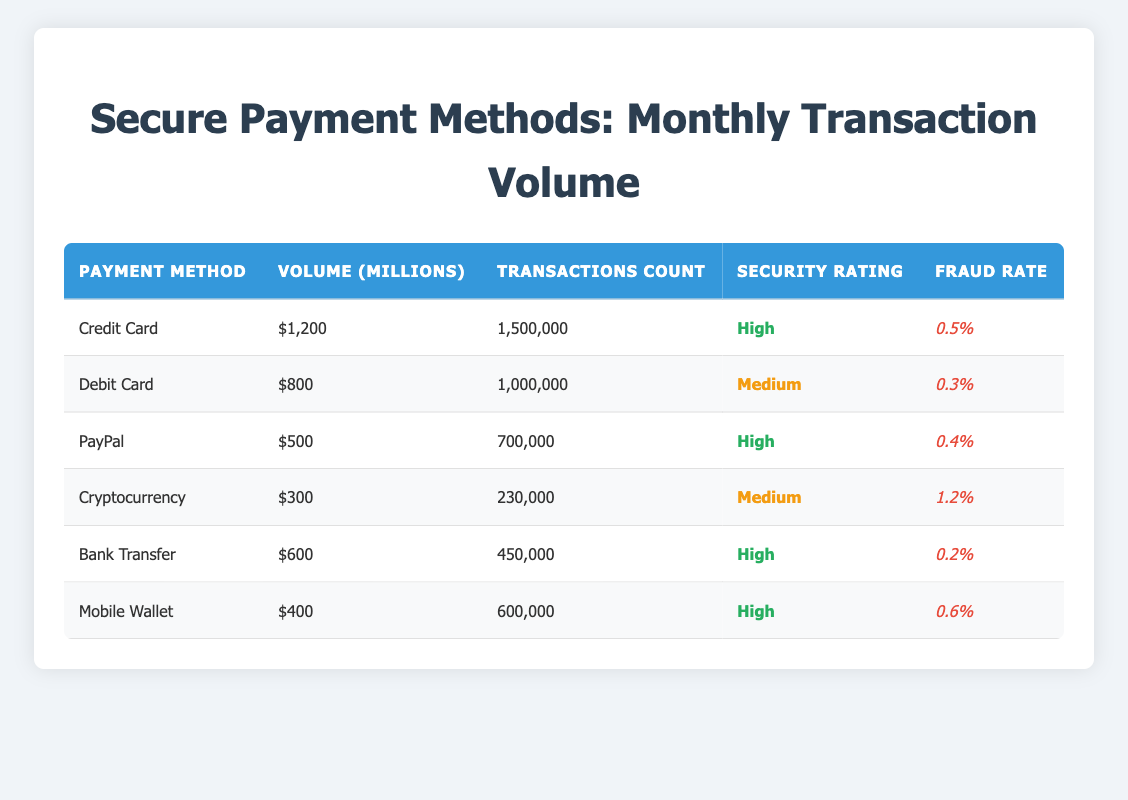What is the payment method with the highest transaction volume? The transaction volumes are as follows: Credit Card - 1200 million, Debit Card - 800 million, PayPal - 500 million, Cryptocurrency - 300 million, Bank Transfer - 600 million, and Mobile Wallet - 400 million. The highest is Credit Card with 1200 million.
Answer: Credit Card How many transactions were made using Debit Cards? According to the table, the Transactions Count for Debit Cards is 1,000,000.
Answer: 1,000,000 What is the average fraud rate of all the payment methods listed? The fraud rates are: Credit Card - 0.5%, Debit Card - 0.3%, PayPal - 0.4%, Cryptocurrency - 1.2%, Bank Transfer - 0.2%, Mobile Wallet - 0.6%. First, convert to decimal: 0.5, 0.3, 0.4, 1.2, 0.2, 0.6 and sum them up (0.5 + 0.3 + 0.4 + 1.2 + 0.2 + 0.6 = 3.2). Since there are 6 payment methods, the average fraud rate is 3.2 / 6 = 0.5333 or 0.53%.
Answer: 0.53% Is the fraud rate for Bank Transfer lower than 1%? The fraud rate for Bank Transfer is 0.2%, which is indeed lower than 1%.
Answer: Yes Which payment methods have a high security rating and what are their transaction counts? The payment methods with a high security rating are Credit Card, PayPal, Bank Transfer, and Mobile Wallet. Their transaction counts are as follows: Credit Card - 1,500,000, PayPal - 700,000, Bank Transfer - 450,000, and Mobile Wallet - 600,000.
Answer: Credit Card: 1,500,000; PayPal: 700,000; Bank Transfer: 450,000; Mobile Wallet: 600,000 What is the difference in transaction count between the payment methods with the highest and lowest counts? The payment method with the highest transaction count is Credit Card with 1,500,000, and the lowest is Cryptocurrency with 230,000. The difference is calculated as 1,500,000 - 230,000 = 1,270,000.
Answer: 1,270,000 Are there more transactions processed via Mobile Wallet than Cryptocurrency? The transaction count for Mobile Wallet is 600,000, while for Cryptocurrency it is 230,000. Since 600,000 is greater than 230,000, there are more transactions for Mobile Wallet.
Answer: Yes Which payment method has the lowest transaction volume among the mediums classified as having a medium security rating? The payment methods with a medium security rating are Debit Card and Cryptocurrency, with volumes of 800 million and 300 million respectively. Thus, Cryptocurrency has the lowest transaction volume of the two.
Answer: Cryptocurrency What is the total transaction volume for all payment methods combined? The total volumes are: Credit Card - 1200 million, Debit Card - 800 million, PayPal - 500 million, Cryptocurrency - 300 million, Bank Transfer - 600 million, and Mobile Wallet - 400 million. To find the total, we sum them up: 1200 + 800 + 500 + 300 + 600 + 400 = 3800 million.
Answer: 3800 million 